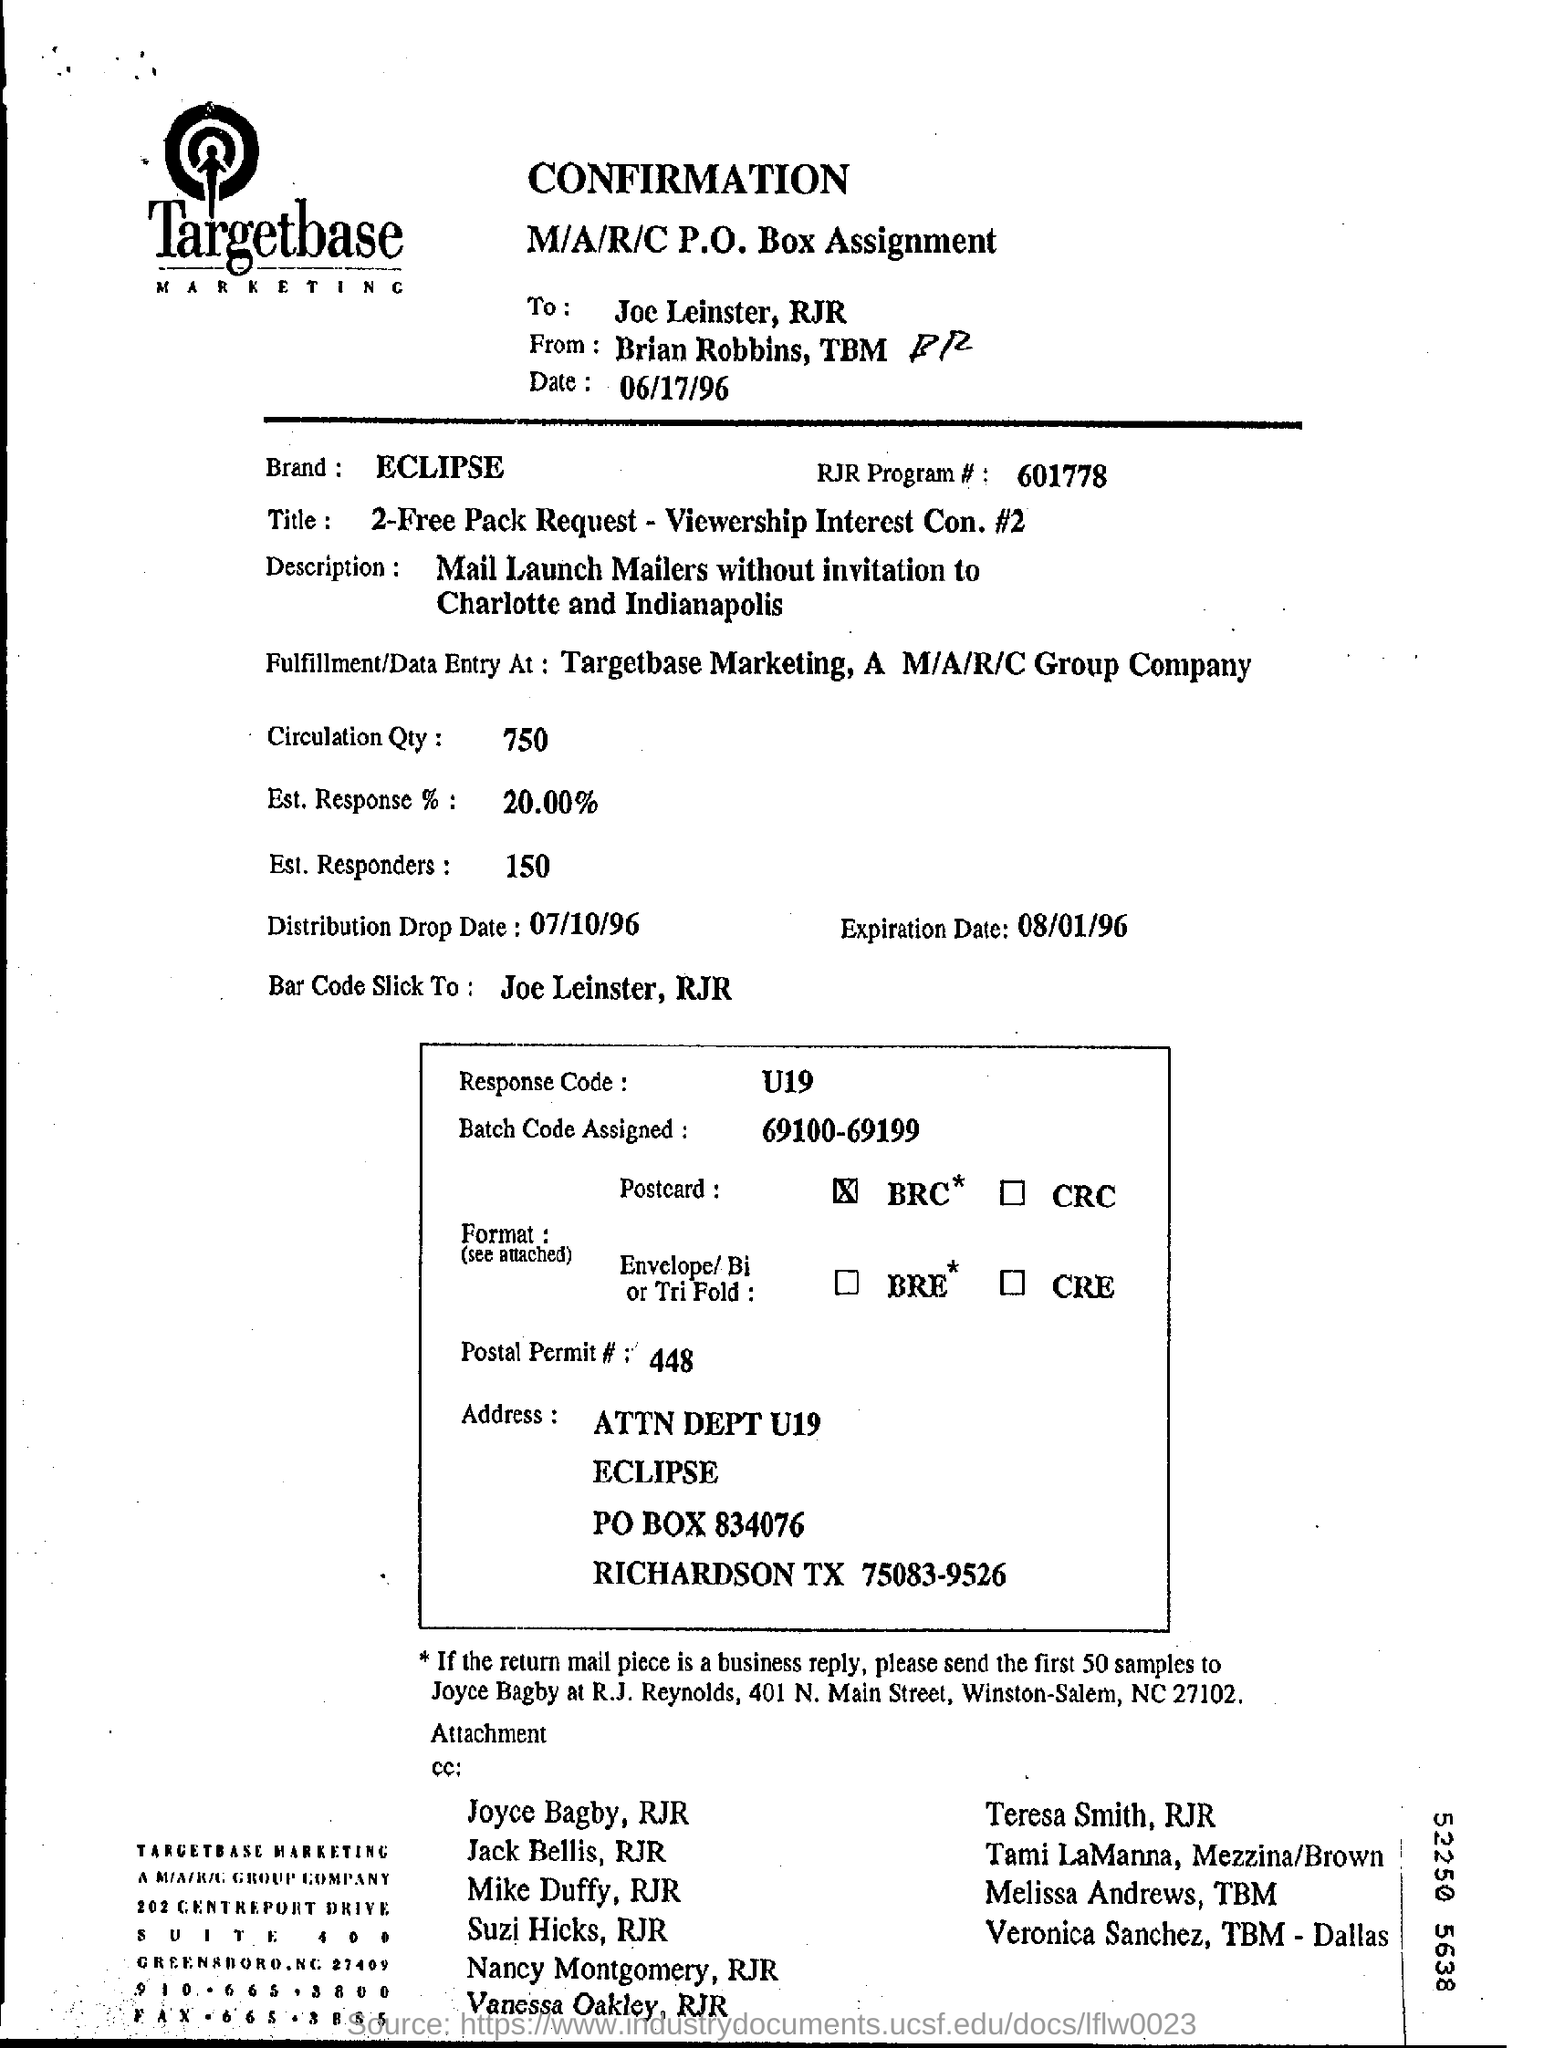What is the name of the brand?
Make the answer very short. ECLIPSE. How many are for the circulation quantity ?
Keep it short and to the point. 750. What is the rate for the est. response%?
Offer a terse response. 20.00%. What is the distribution drop date?
Provide a short and direct response. 07/10/96. What is the date of the expiration date?
Provide a short and direct response. 08/01/96. What is the number rjr program# ?
Give a very brief answer. 601778. To whom  brian robbins,tbm sending for confirmation ?
Make the answer very short. Joe Leinster. What is the code for the response?
Keep it short and to the point. U19. 